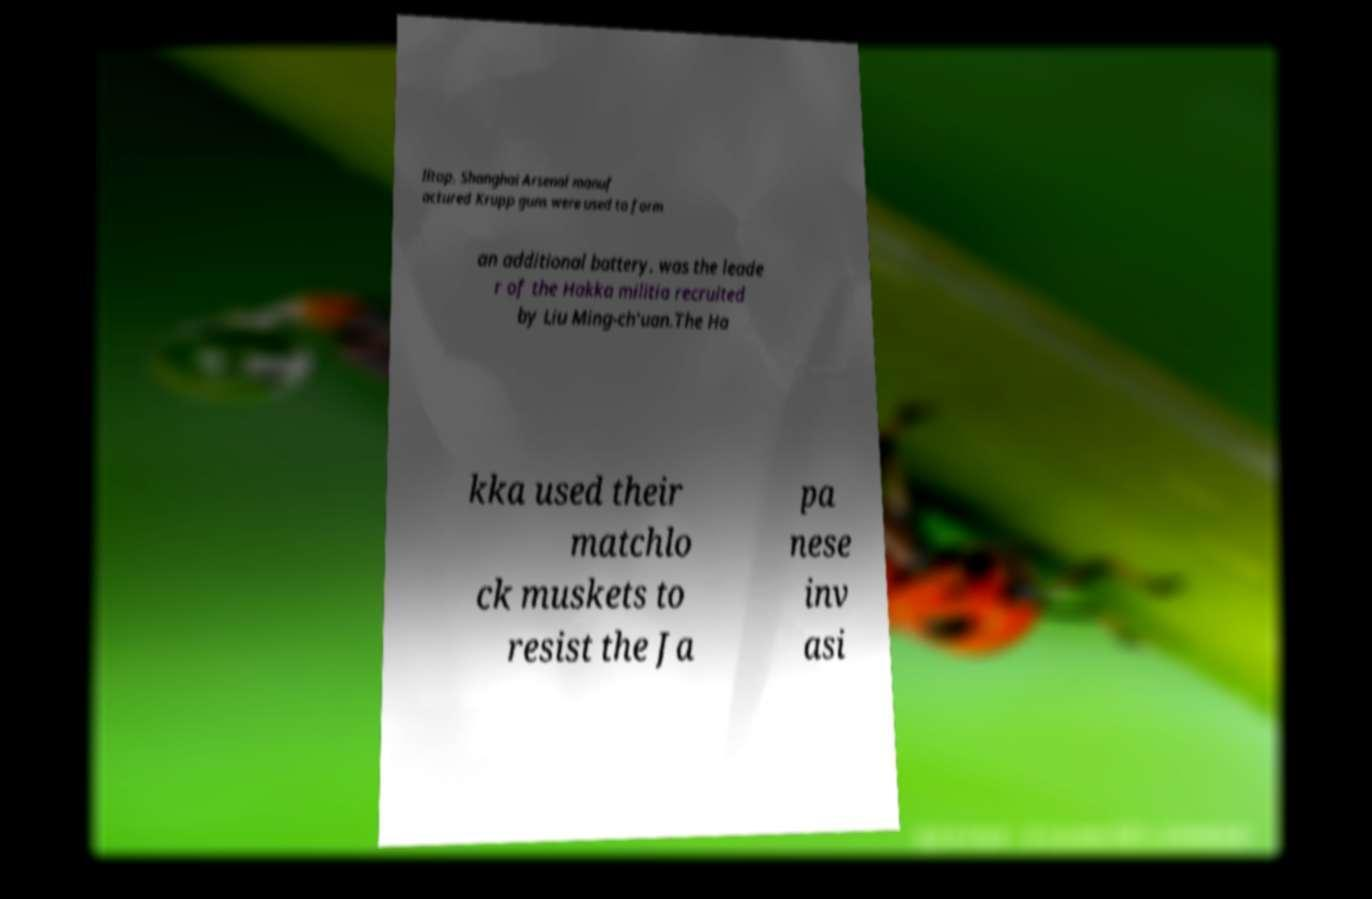Could you assist in decoding the text presented in this image and type it out clearly? lltop, Shanghai Arsenal manuf actured Krupp guns were used to form an additional battery. was the leade r of the Hakka militia recruited by Liu Ming-ch'uan.The Ha kka used their matchlo ck muskets to resist the Ja pa nese inv asi 